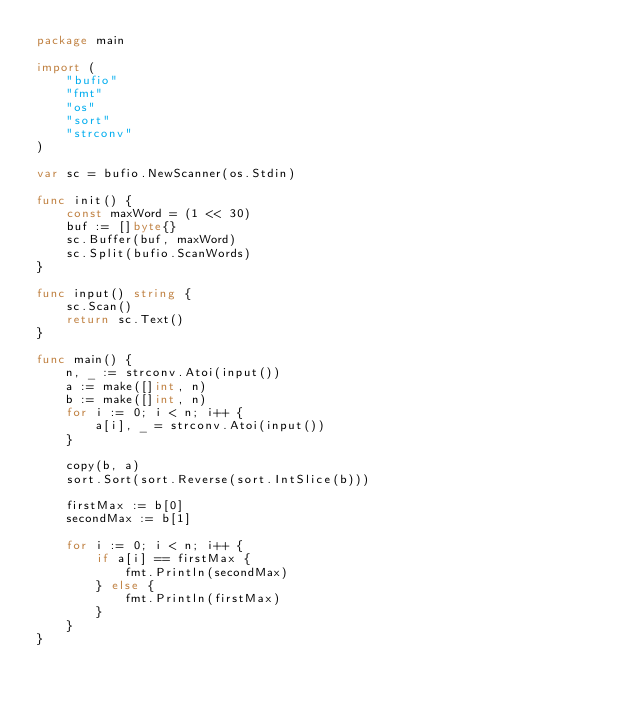<code> <loc_0><loc_0><loc_500><loc_500><_Go_>package main

import (
	"bufio"
	"fmt"
	"os"
	"sort"
	"strconv"
)

var sc = bufio.NewScanner(os.Stdin)

func init() {
	const maxWord = (1 << 30)
	buf := []byte{}
	sc.Buffer(buf, maxWord)
	sc.Split(bufio.ScanWords)
}

func input() string {
	sc.Scan()
	return sc.Text()
}

func main() {
	n, _ := strconv.Atoi(input())
	a := make([]int, n)
	b := make([]int, n)
	for i := 0; i < n; i++ {
		a[i], _ = strconv.Atoi(input())
	}

	copy(b, a)
	sort.Sort(sort.Reverse(sort.IntSlice(b)))

	firstMax := b[0]
	secondMax := b[1]

	for i := 0; i < n; i++ {
		if a[i] == firstMax {
			fmt.Println(secondMax)
		} else {
			fmt.Println(firstMax)
		}
	}
}
</code> 